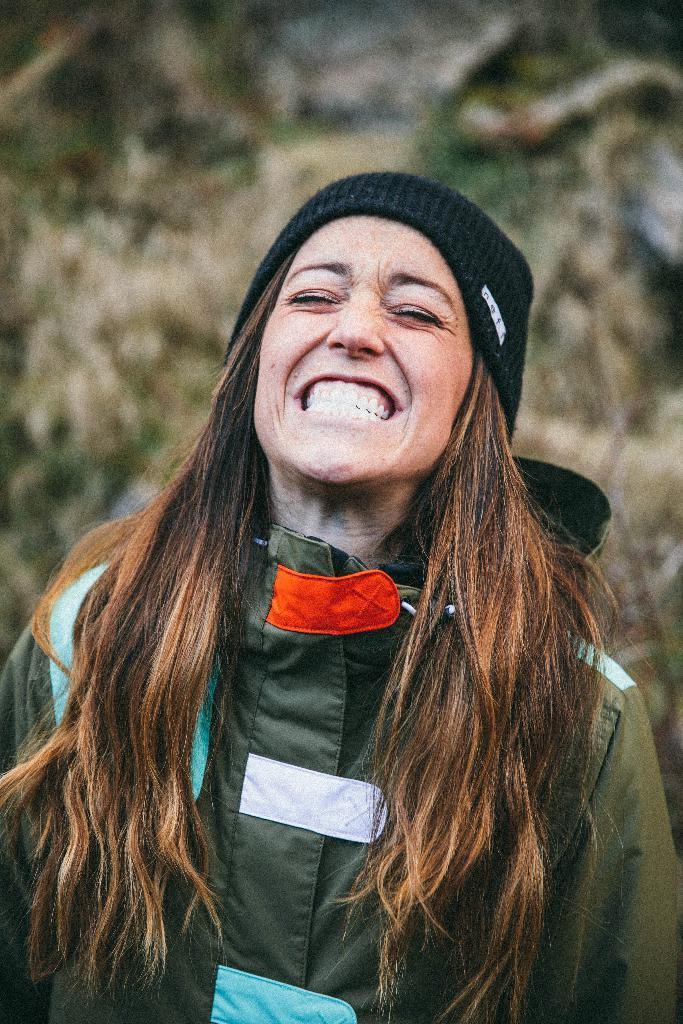Who is the main subject in the image? There is a woman in the image. Where is the woman positioned in the image? The woman is standing in the middle of the image. What can be seen in the background of the image? There are trees in the background of the image. How long does it take for the actor to walk across the room in the image? There is no actor or room present in the image, so it is not possible to answer that question. 